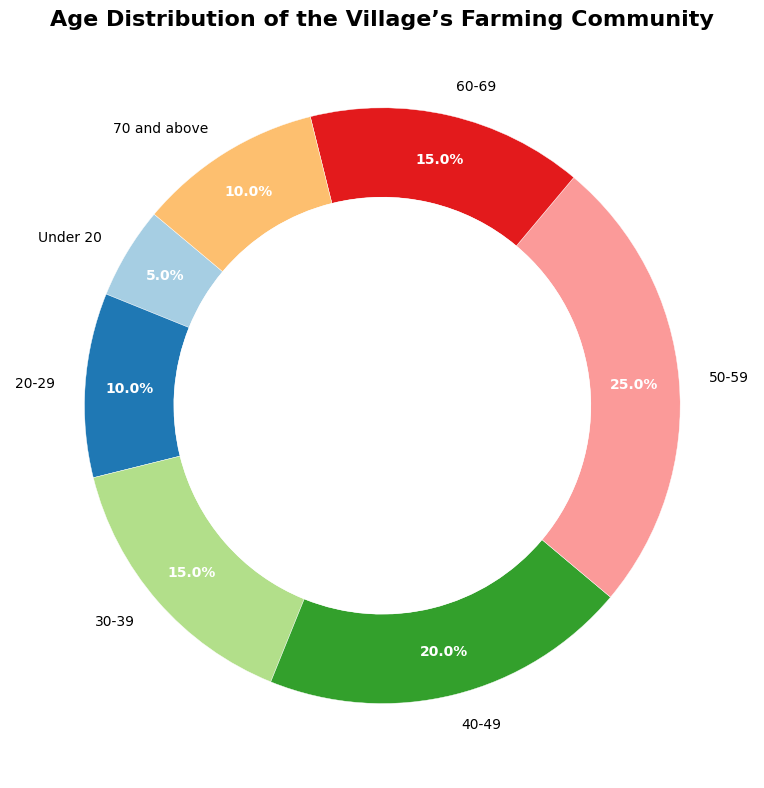How many age groups have a population of 15 or more? First, identify all age groups with a population of 15 or more. Those are 30-39 (15), 40-49 (20), 50-59 (25), and 60-69 (15). Count these groups.
Answer: 4 Which age group has the largest population? Identify the age group with the highest numerical value. The largest population is 25, which belongs to the age group 50-59.
Answer: 50-59 What is the total population represented in the chart? Sum the populations of all age groups: 5 (Under 20) + 10 (20-29) + 15 (30-39) + 20 (40-49) + 25 (50-59) + 15 (60-69) + 10 (70 and above) = 100.
Answer: 100 What percentage of the population is aged 50 and above? Sum the populations of age groups 50-59, 60-69, and 70 and above: 25 (50-59) + 15 (60-69) + 10 (70 and above) = 50. Then, calculate the percentage: (50/100) * 100 = 50%.
Answer: 50% Is the population of the 30-39 age group greater than the population of the Under 20 and the 20-29 age groups combined? Combine the populations of Under 20 (5) and 20-29 (10): 5 + 10 = 15. Compare this to the population of the 30-39 age group (15).
Answer: No Which age groups make up the smallest and largest segments of the chart? Find the smallest and largest populations. The smallest segment is the Under 20 age group with 5 people, and the largest segment is the 50-59 age group with 25 people.
Answer: Under 20 and 50-59 What is the ratio of the population of the 40-49 age group to the 20-29 age group? The population of the 40-49 age group is 20, and the population of the 20-29 age group is 10. The ratio is 20/10 = 2:1.
Answer: 2:1 If 5 people are added to each age group, what would be the new total population? Add 5 to each group's population and sum them: (5+5) + (10+5) + (15+5) + (20+5) + (25+5) + (15+5) + (10+5) = 10 + 15 + 20 + 25 + 30 + 20 + 15 = 135.
Answer: 135 